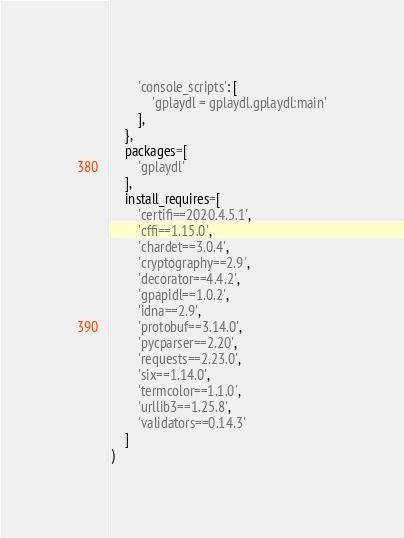<code> <loc_0><loc_0><loc_500><loc_500><_Python_>		'console_scripts': [
			'gplaydl = gplaydl.gplaydl:main'
		],
	},
	packages=[
		'gplaydl'
	],
	install_requires=[
		'certifi==2020.4.5.1',
		'cffi==1.15.0',
		'chardet==3.0.4',
		'cryptography==2.9',
		'decorator==4.4.2',
		'gpapidl==1.0.2',
		'idna==2.9',
		'protobuf==3.14.0',
		'pycparser==2.20',
		'requests==2.23.0',
		'six==1.14.0',
		'termcolor==1.1.0',
		'urllib3==1.25.8',
		'validators==0.14.3'
	]
)
</code> 